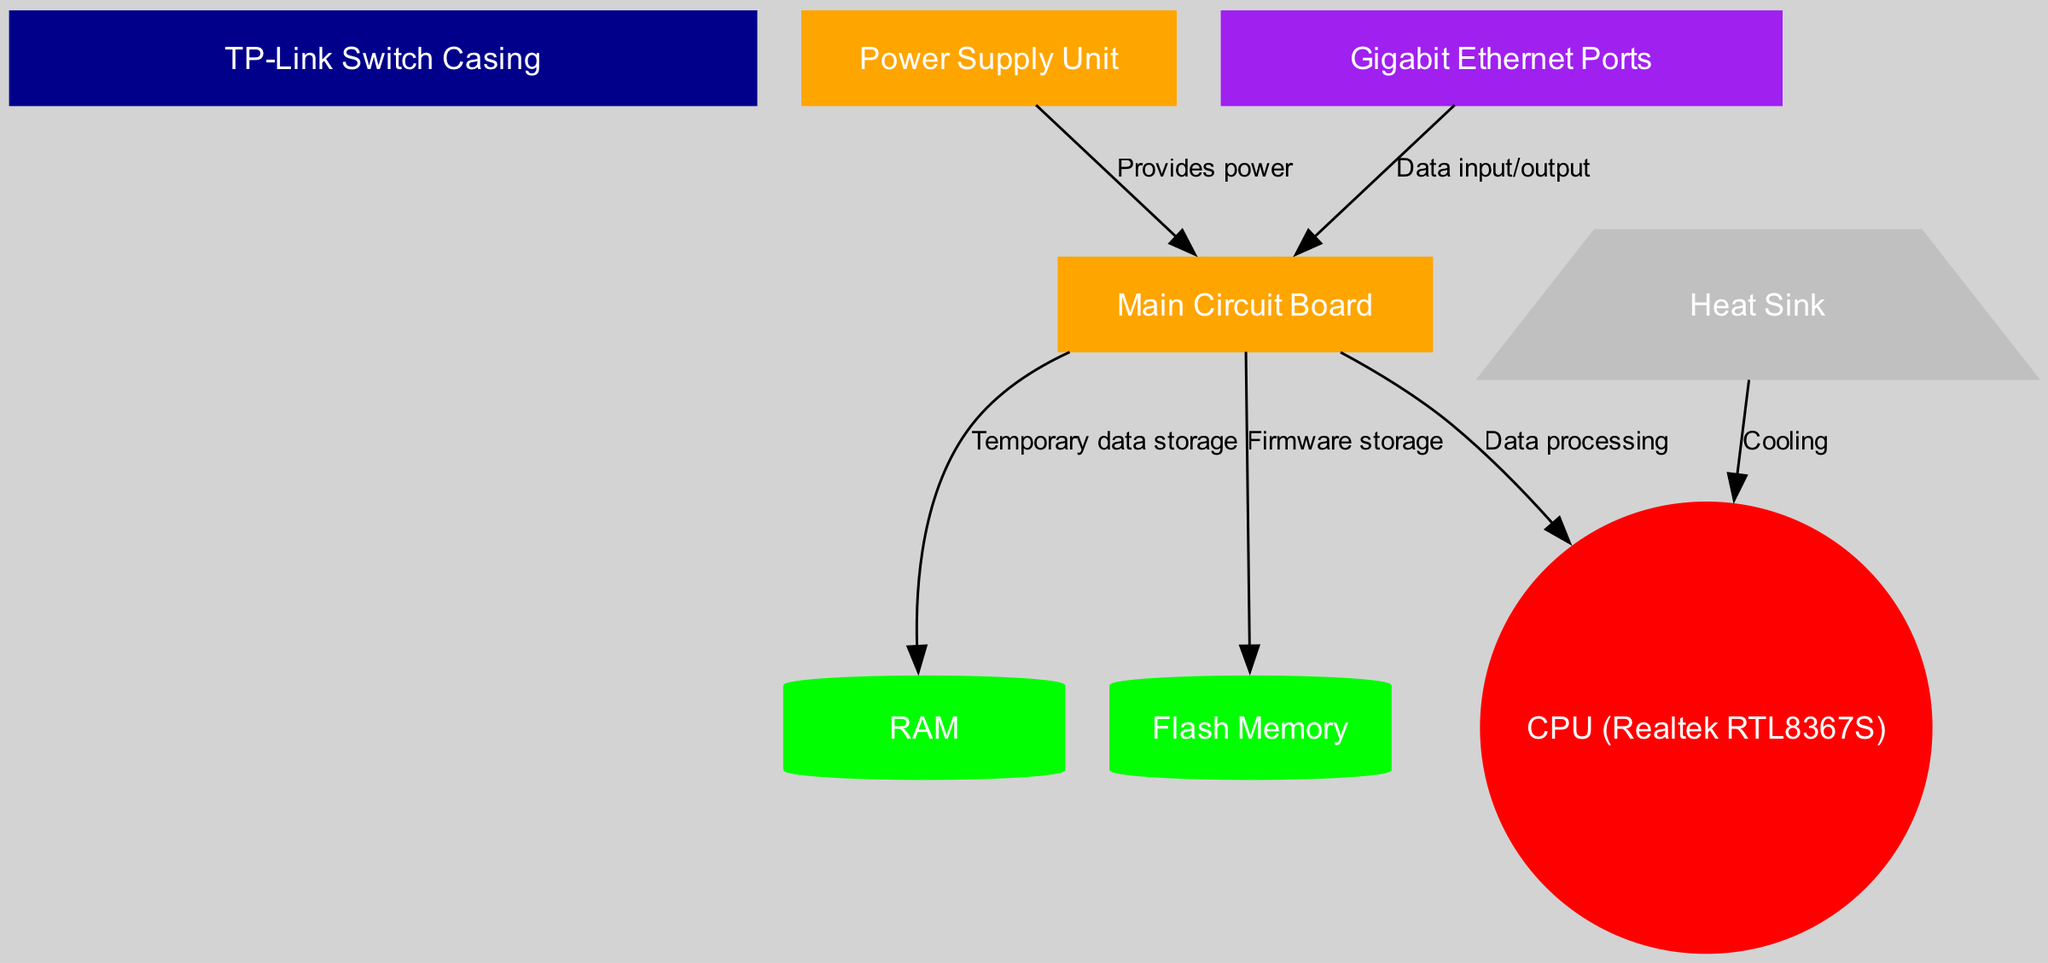What are the main components depicted in the diagram? The diagram showcases several components like the switch casing, power supply unit, main circuit board, CPU, RAM, flash memory, Gigabit Ethernet ports, and heat sink. These are all labeled clearly in the diagram.
Answer: TP-Link Switch Casing, Power Supply Unit, Main Circuit Board, CPU, RAM, Flash Memory, Gigabit Ethernet Ports, Heat Sink How many edges are present in the diagram? The diagram has seven edges that represent connections between the various components and their functions, indicating how data flows and power is provided throughout the switch.
Answer: 7 Which component provides power to the main circuit board? The diagram indicates that the power supply unit is connected to the main circuit board with an edge labeled "Provides power," showing the direction of the relationship.
Answer: Power Supply Unit What is the function of the heat sink? The heat sink is shown to connect to the CPU, with an edge labeled "Cooling," which signifies its role in dissipating heat generated by the CPU.
Answer: Cooling Which components are used for data storage? The diagram features two components connected to the main board for storage: RAM, labeled as "Temporary data storage," and flash memory, labeled as "Firmware storage," indicating their respective roles.
Answer: RAM, Flash Memory How does data enter and exit the switch? The Gigabit Ethernet ports connect to the main board with an edge labeled "Data input/output," indicating that all data flow to and from the switch occurs through these ports.
Answer: Gigabit Ethernet Ports What type of CPU is used in this TP-Link switch? The diagram labels the CPU as "Realtek RTL8367S," allowing us to identify the specific type of CPU utilized in the switch.
Answer: Realtek RTL8367S Which component connects to the CPU for cooling? The diagram shows that the heat sink connects to the CPU with an edge labeled "Cooling," indicating its function in managing the CPU's temperature.
Answer: Heat Sink 